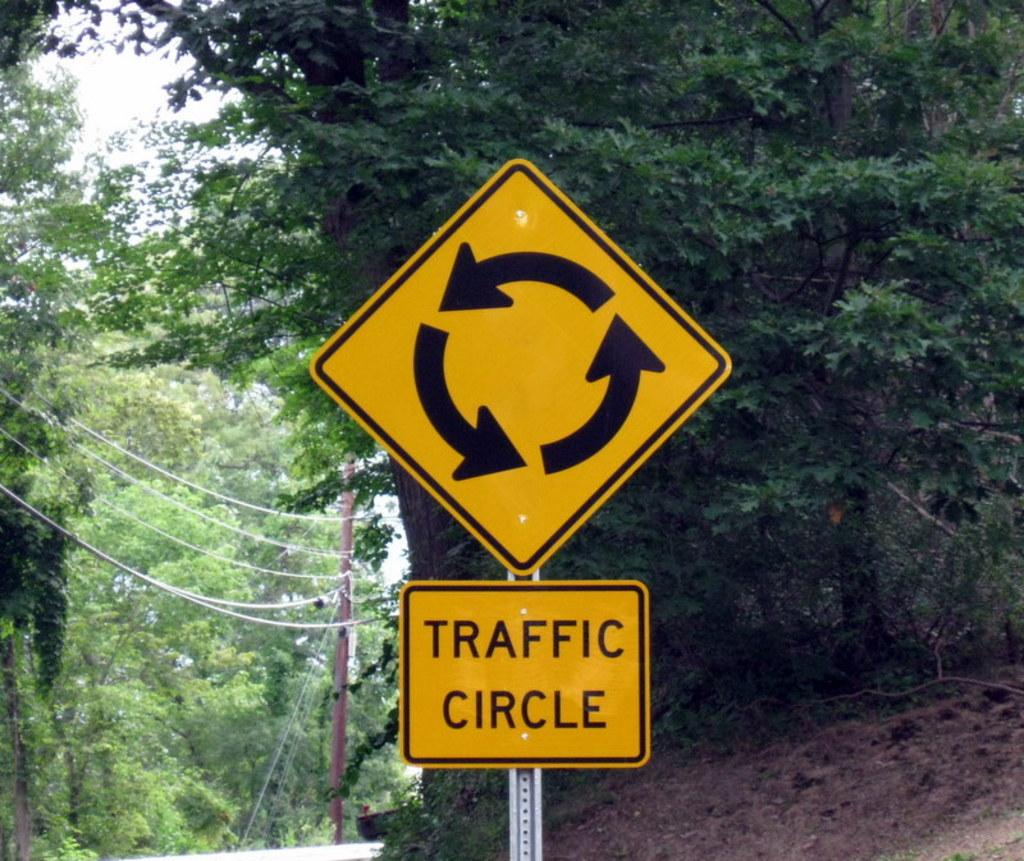Provide a one-sentence caption for the provided image. A sign is telling you this is a traffic circle. 